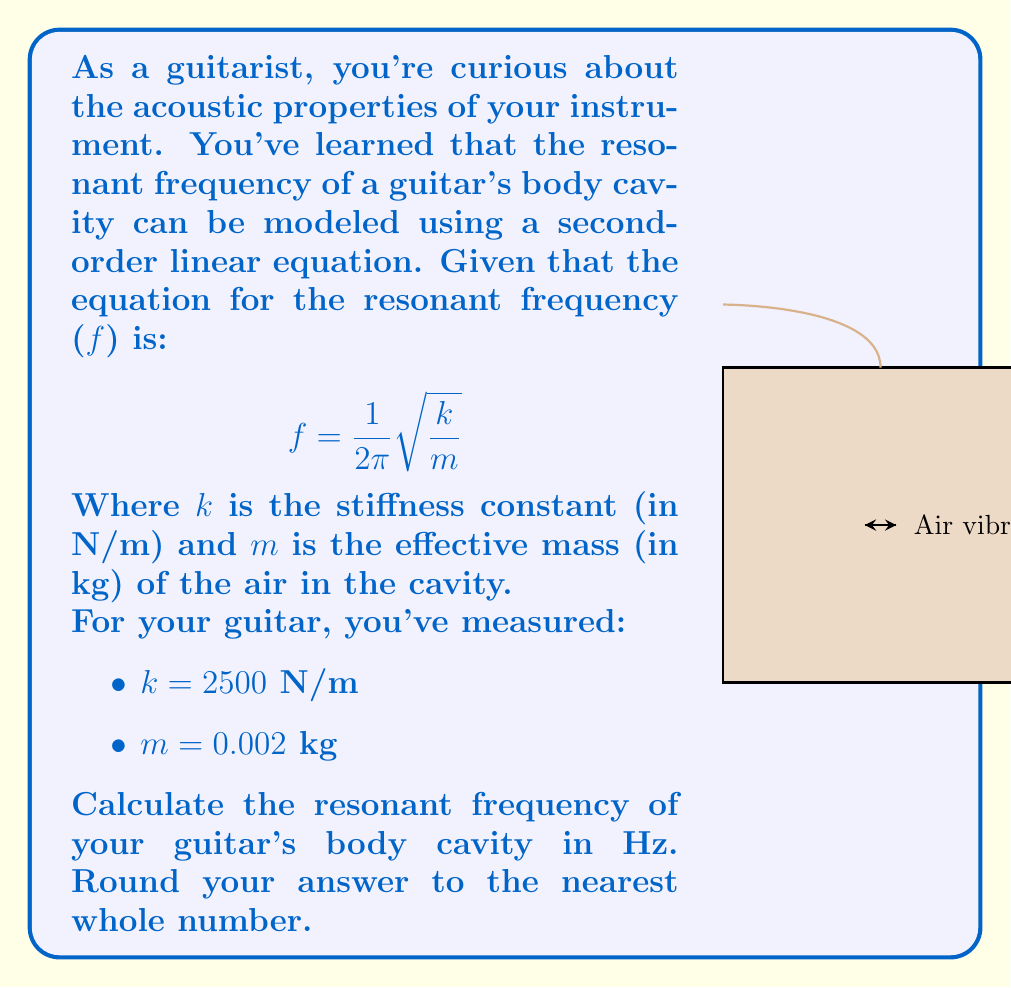Solve this math problem. Let's approach this step-by-step:

1) We're given the equation for resonant frequency:
   $$f = \frac{1}{2\pi}\sqrt{\frac{k}{m}}$$

2) We're also given the values:
   k = 2500 N/m
   m = 0.002 kg

3) Let's substitute these values into our equation:
   $$f = \frac{1}{2\pi}\sqrt{\frac{2500}{0.002}}$$

4) First, let's calculate what's inside the square root:
   $$\frac{2500}{0.002} = 1,250,000$$

5) Now our equation looks like:
   $$f = \frac{1}{2\pi}\sqrt{1,250,000}$$

6) Let's calculate the square root:
   $$\sqrt{1,250,000} = 1118.033988749895$$

7) Now we have:
   $$f = \frac{1}{2\pi} * 1118.033988749895$$

8) Calculate:
   $$f = 177.98550087873877$$

9) Rounding to the nearest whole number:
   f ≈ 178 Hz
Answer: 178 Hz 